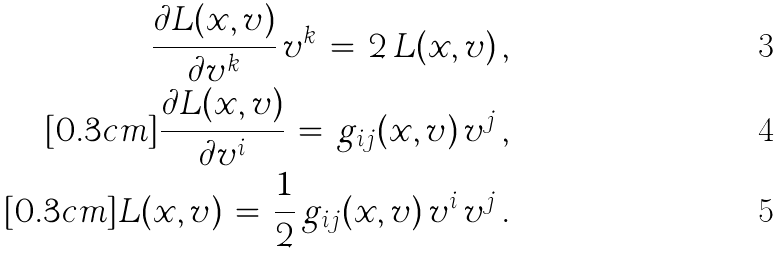Convert formula to latex. <formula><loc_0><loc_0><loc_500><loc_500>\frac { \partial L ( x , v ) } { \partial v ^ { k } } \, v ^ { k } \, = \, 2 \, L ( x , v ) \, , \\ [ 0 . 3 c m ] \frac { \partial L ( x , v ) } { \partial v ^ { i } } \, = \, g _ { i j } ( x , v ) \, v ^ { j } \, , \\ [ 0 . 3 c m ] L ( x , v ) \, = \, \frac { 1 } { 2 } \, g _ { i j } ( x , v ) \, v ^ { i } \, v ^ { j } \, .</formula> 